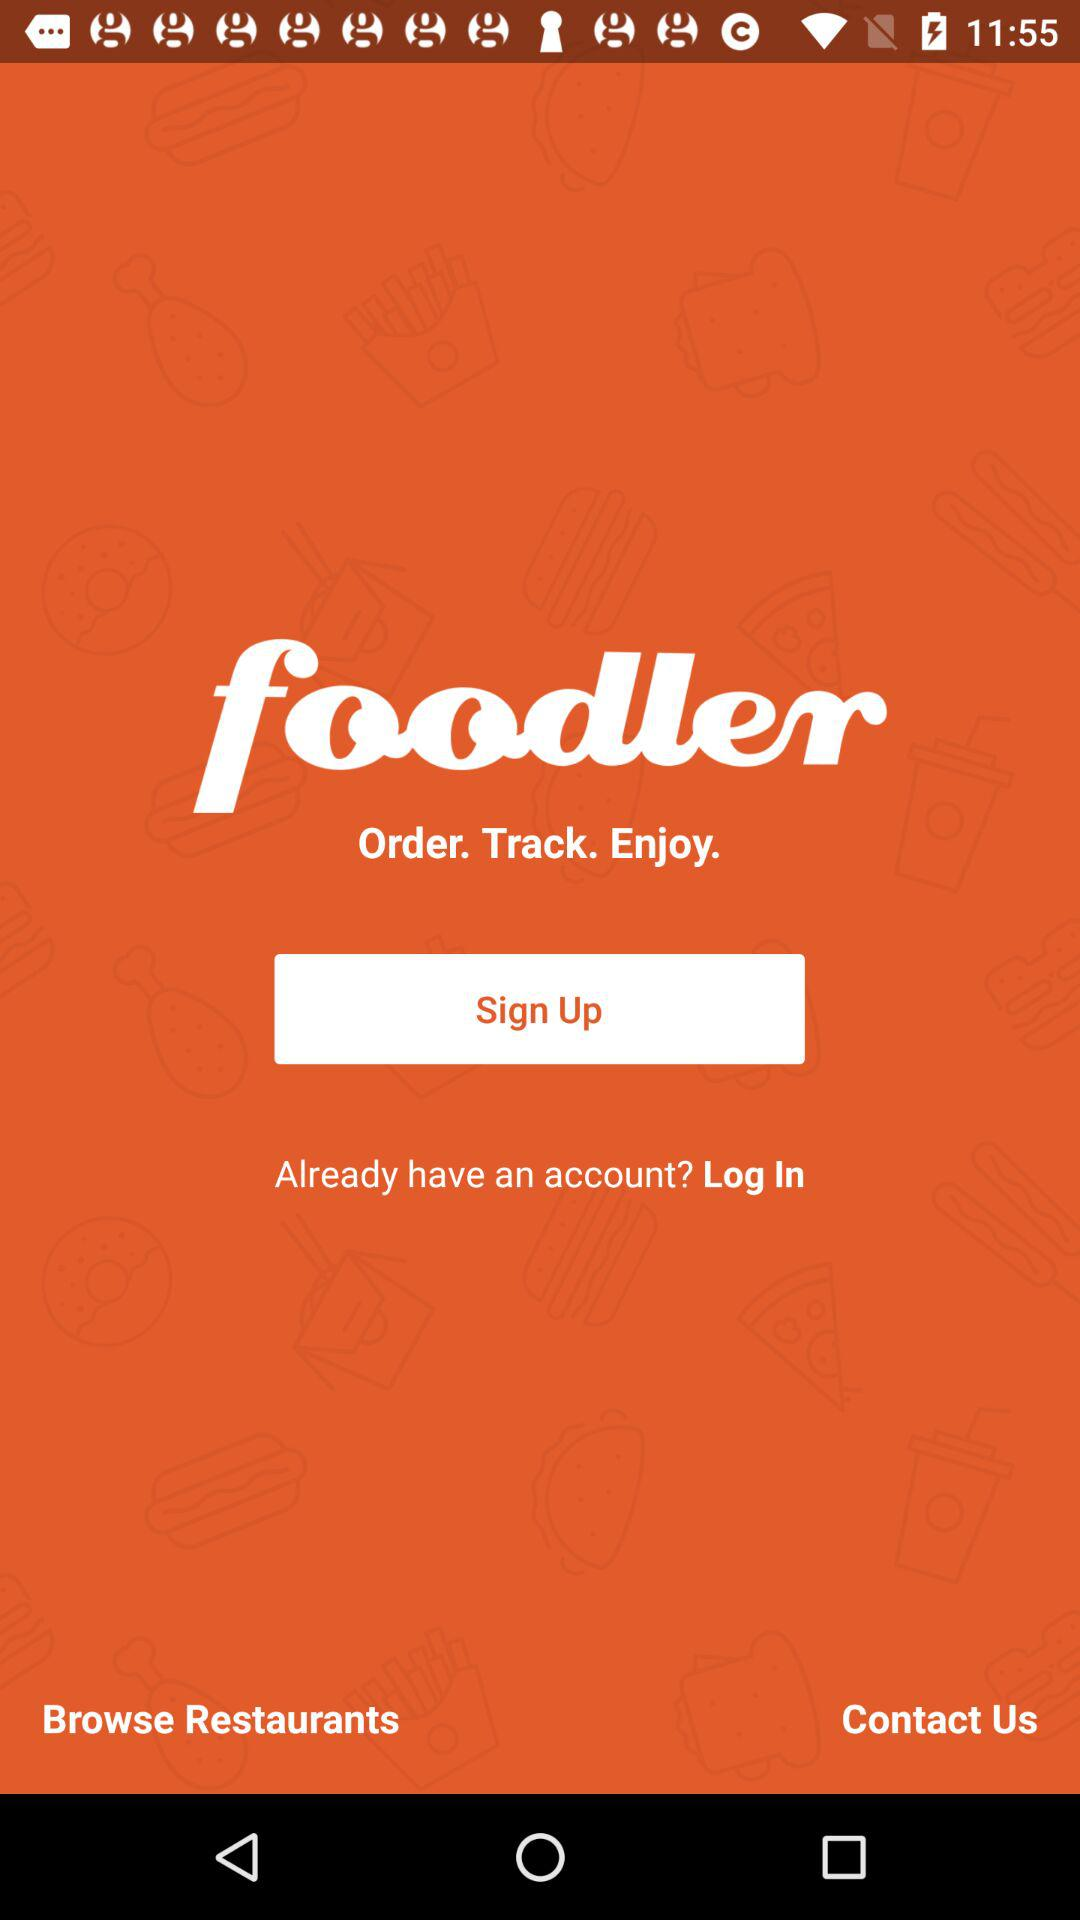What is the name of the application? The name of the application is "foodler". 